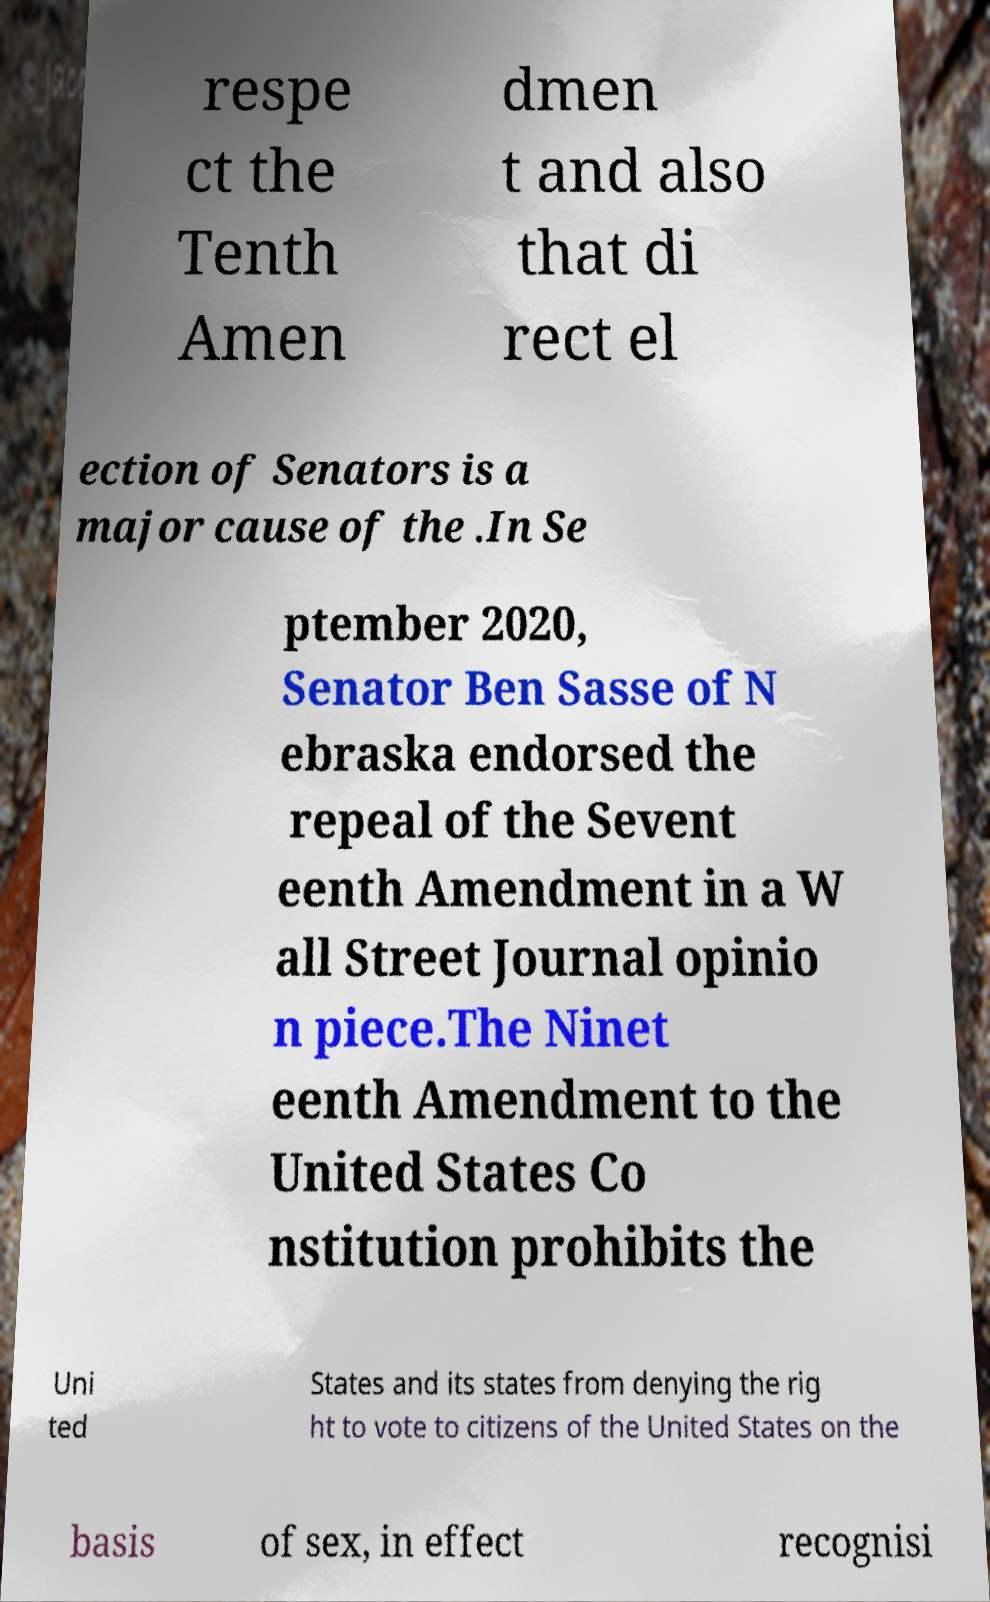Can you read and provide the text displayed in the image?This photo seems to have some interesting text. Can you extract and type it out for me? respe ct the Tenth Amen dmen t and also that di rect el ection of Senators is a major cause of the .In Se ptember 2020, Senator Ben Sasse of N ebraska endorsed the repeal of the Sevent eenth Amendment in a W all Street Journal opinio n piece.The Ninet eenth Amendment to the United States Co nstitution prohibits the Uni ted States and its states from denying the rig ht to vote to citizens of the United States on the basis of sex, in effect recognisi 